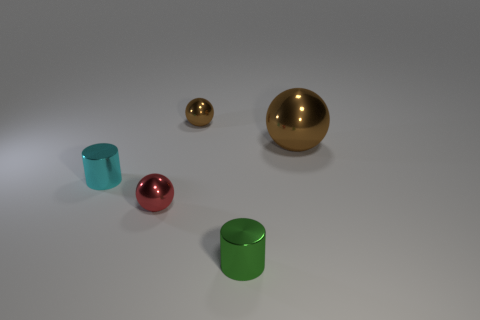How many metal objects are behind the tiny cyan thing and in front of the red thing?
Your response must be concise. 0. There is a metallic cylinder to the right of the cyan object; is its size the same as the cyan cylinder?
Your response must be concise. Yes. Are there any other spheres of the same color as the big metallic sphere?
Make the answer very short. Yes. The red thing that is made of the same material as the big ball is what size?
Offer a very short reply. Small. Is the number of big metallic objects in front of the big metal thing greater than the number of large balls that are in front of the cyan metallic cylinder?
Offer a very short reply. No. What number of other things are made of the same material as the cyan cylinder?
Provide a short and direct response. 4. Is the cylinder on the left side of the green metal object made of the same material as the tiny green thing?
Your answer should be very brief. Yes. What is the shape of the small cyan thing?
Make the answer very short. Cylinder. Are there more things in front of the small green cylinder than small objects?
Ensure brevity in your answer.  No. Is there anything else that is the same shape as the red metallic thing?
Keep it short and to the point. Yes. 